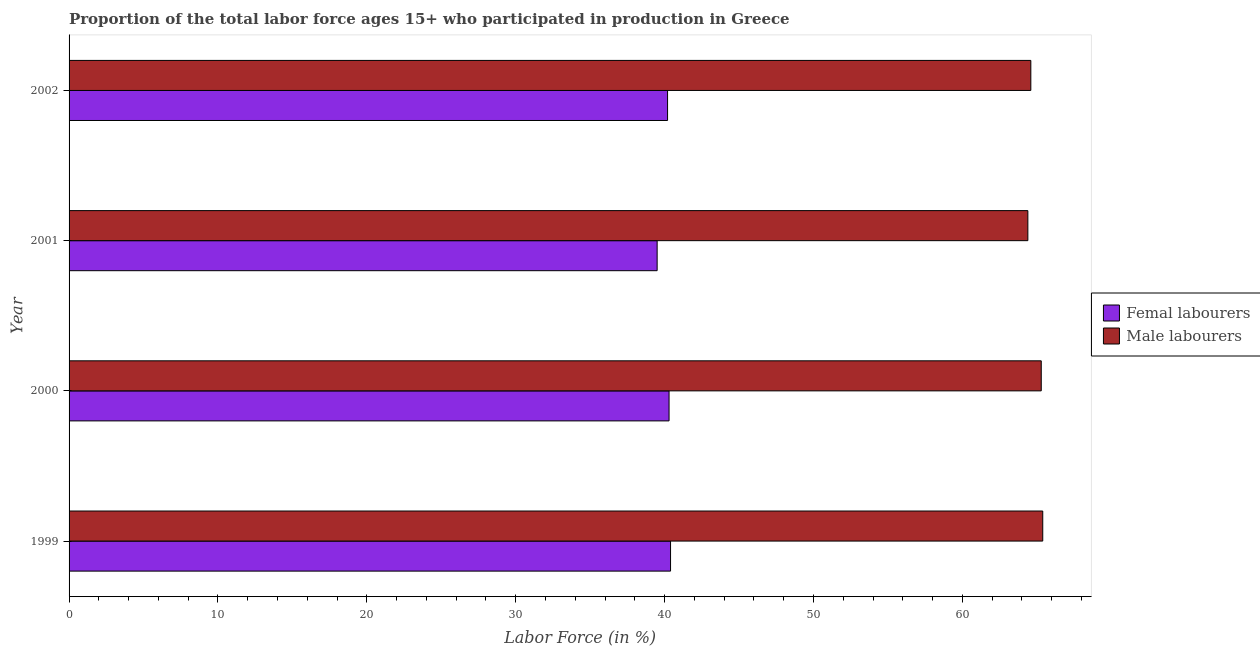Are the number of bars per tick equal to the number of legend labels?
Offer a terse response. Yes. How many bars are there on the 2nd tick from the top?
Your answer should be compact. 2. What is the label of the 3rd group of bars from the top?
Your answer should be very brief. 2000. In how many cases, is the number of bars for a given year not equal to the number of legend labels?
Give a very brief answer. 0. What is the percentage of female labor force in 2000?
Provide a succinct answer. 40.3. Across all years, what is the maximum percentage of male labour force?
Provide a succinct answer. 65.4. Across all years, what is the minimum percentage of male labour force?
Offer a terse response. 64.4. What is the total percentage of female labor force in the graph?
Keep it short and to the point. 160.4. What is the difference between the percentage of female labor force in 2000 and the percentage of male labour force in 2002?
Your answer should be compact. -24.3. What is the average percentage of male labour force per year?
Ensure brevity in your answer.  64.92. Is the difference between the percentage of female labor force in 1999 and 2001 greater than the difference between the percentage of male labour force in 1999 and 2001?
Offer a very short reply. No. What is the difference between the highest and the lowest percentage of female labor force?
Keep it short and to the point. 0.9. In how many years, is the percentage of male labour force greater than the average percentage of male labour force taken over all years?
Make the answer very short. 2. What does the 1st bar from the top in 2001 represents?
Make the answer very short. Male labourers. What does the 2nd bar from the bottom in 2002 represents?
Keep it short and to the point. Male labourers. How many bars are there?
Give a very brief answer. 8. Are the values on the major ticks of X-axis written in scientific E-notation?
Keep it short and to the point. No. Where does the legend appear in the graph?
Give a very brief answer. Center right. What is the title of the graph?
Ensure brevity in your answer.  Proportion of the total labor force ages 15+ who participated in production in Greece. Does "Attending school" appear as one of the legend labels in the graph?
Keep it short and to the point. No. What is the Labor Force (in %) of Femal labourers in 1999?
Offer a very short reply. 40.4. What is the Labor Force (in %) of Male labourers in 1999?
Keep it short and to the point. 65.4. What is the Labor Force (in %) of Femal labourers in 2000?
Keep it short and to the point. 40.3. What is the Labor Force (in %) in Male labourers in 2000?
Make the answer very short. 65.3. What is the Labor Force (in %) of Femal labourers in 2001?
Your response must be concise. 39.5. What is the Labor Force (in %) of Male labourers in 2001?
Give a very brief answer. 64.4. What is the Labor Force (in %) of Femal labourers in 2002?
Ensure brevity in your answer.  40.2. What is the Labor Force (in %) in Male labourers in 2002?
Your answer should be compact. 64.6. Across all years, what is the maximum Labor Force (in %) in Femal labourers?
Give a very brief answer. 40.4. Across all years, what is the maximum Labor Force (in %) in Male labourers?
Offer a very short reply. 65.4. Across all years, what is the minimum Labor Force (in %) in Femal labourers?
Give a very brief answer. 39.5. Across all years, what is the minimum Labor Force (in %) of Male labourers?
Provide a succinct answer. 64.4. What is the total Labor Force (in %) in Femal labourers in the graph?
Give a very brief answer. 160.4. What is the total Labor Force (in %) in Male labourers in the graph?
Offer a terse response. 259.7. What is the difference between the Labor Force (in %) of Femal labourers in 1999 and that in 2001?
Ensure brevity in your answer.  0.9. What is the difference between the Labor Force (in %) of Male labourers in 1999 and that in 2002?
Provide a succinct answer. 0.8. What is the difference between the Labor Force (in %) in Femal labourers in 2001 and that in 2002?
Provide a succinct answer. -0.7. What is the difference between the Labor Force (in %) in Male labourers in 2001 and that in 2002?
Provide a short and direct response. -0.2. What is the difference between the Labor Force (in %) of Femal labourers in 1999 and the Labor Force (in %) of Male labourers in 2000?
Your answer should be very brief. -24.9. What is the difference between the Labor Force (in %) of Femal labourers in 1999 and the Labor Force (in %) of Male labourers in 2002?
Your response must be concise. -24.2. What is the difference between the Labor Force (in %) of Femal labourers in 2000 and the Labor Force (in %) of Male labourers in 2001?
Your answer should be very brief. -24.1. What is the difference between the Labor Force (in %) of Femal labourers in 2000 and the Labor Force (in %) of Male labourers in 2002?
Your answer should be very brief. -24.3. What is the difference between the Labor Force (in %) in Femal labourers in 2001 and the Labor Force (in %) in Male labourers in 2002?
Give a very brief answer. -25.1. What is the average Labor Force (in %) of Femal labourers per year?
Keep it short and to the point. 40.1. What is the average Labor Force (in %) in Male labourers per year?
Keep it short and to the point. 64.92. In the year 1999, what is the difference between the Labor Force (in %) of Femal labourers and Labor Force (in %) of Male labourers?
Provide a succinct answer. -25. In the year 2000, what is the difference between the Labor Force (in %) of Femal labourers and Labor Force (in %) of Male labourers?
Your answer should be compact. -25. In the year 2001, what is the difference between the Labor Force (in %) of Femal labourers and Labor Force (in %) of Male labourers?
Your answer should be compact. -24.9. In the year 2002, what is the difference between the Labor Force (in %) in Femal labourers and Labor Force (in %) in Male labourers?
Your response must be concise. -24.4. What is the ratio of the Labor Force (in %) in Male labourers in 1999 to that in 2000?
Make the answer very short. 1. What is the ratio of the Labor Force (in %) of Femal labourers in 1999 to that in 2001?
Offer a terse response. 1.02. What is the ratio of the Labor Force (in %) of Male labourers in 1999 to that in 2001?
Offer a terse response. 1.02. What is the ratio of the Labor Force (in %) in Femal labourers in 1999 to that in 2002?
Provide a short and direct response. 1. What is the ratio of the Labor Force (in %) in Male labourers in 1999 to that in 2002?
Provide a short and direct response. 1.01. What is the ratio of the Labor Force (in %) in Femal labourers in 2000 to that in 2001?
Give a very brief answer. 1.02. What is the ratio of the Labor Force (in %) in Male labourers in 2000 to that in 2002?
Give a very brief answer. 1.01. What is the ratio of the Labor Force (in %) in Femal labourers in 2001 to that in 2002?
Provide a succinct answer. 0.98. What is the difference between the highest and the second highest Labor Force (in %) in Male labourers?
Offer a very short reply. 0.1. What is the difference between the highest and the lowest Labor Force (in %) in Male labourers?
Give a very brief answer. 1. 